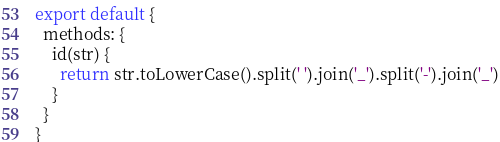Convert code to text. <code><loc_0><loc_0><loc_500><loc_500><_JavaScript_>export default {
  methods: {
    id(str) {
      return str.toLowerCase().split(' ').join('_').split('-').join('_')
    }
  }
}
</code> 